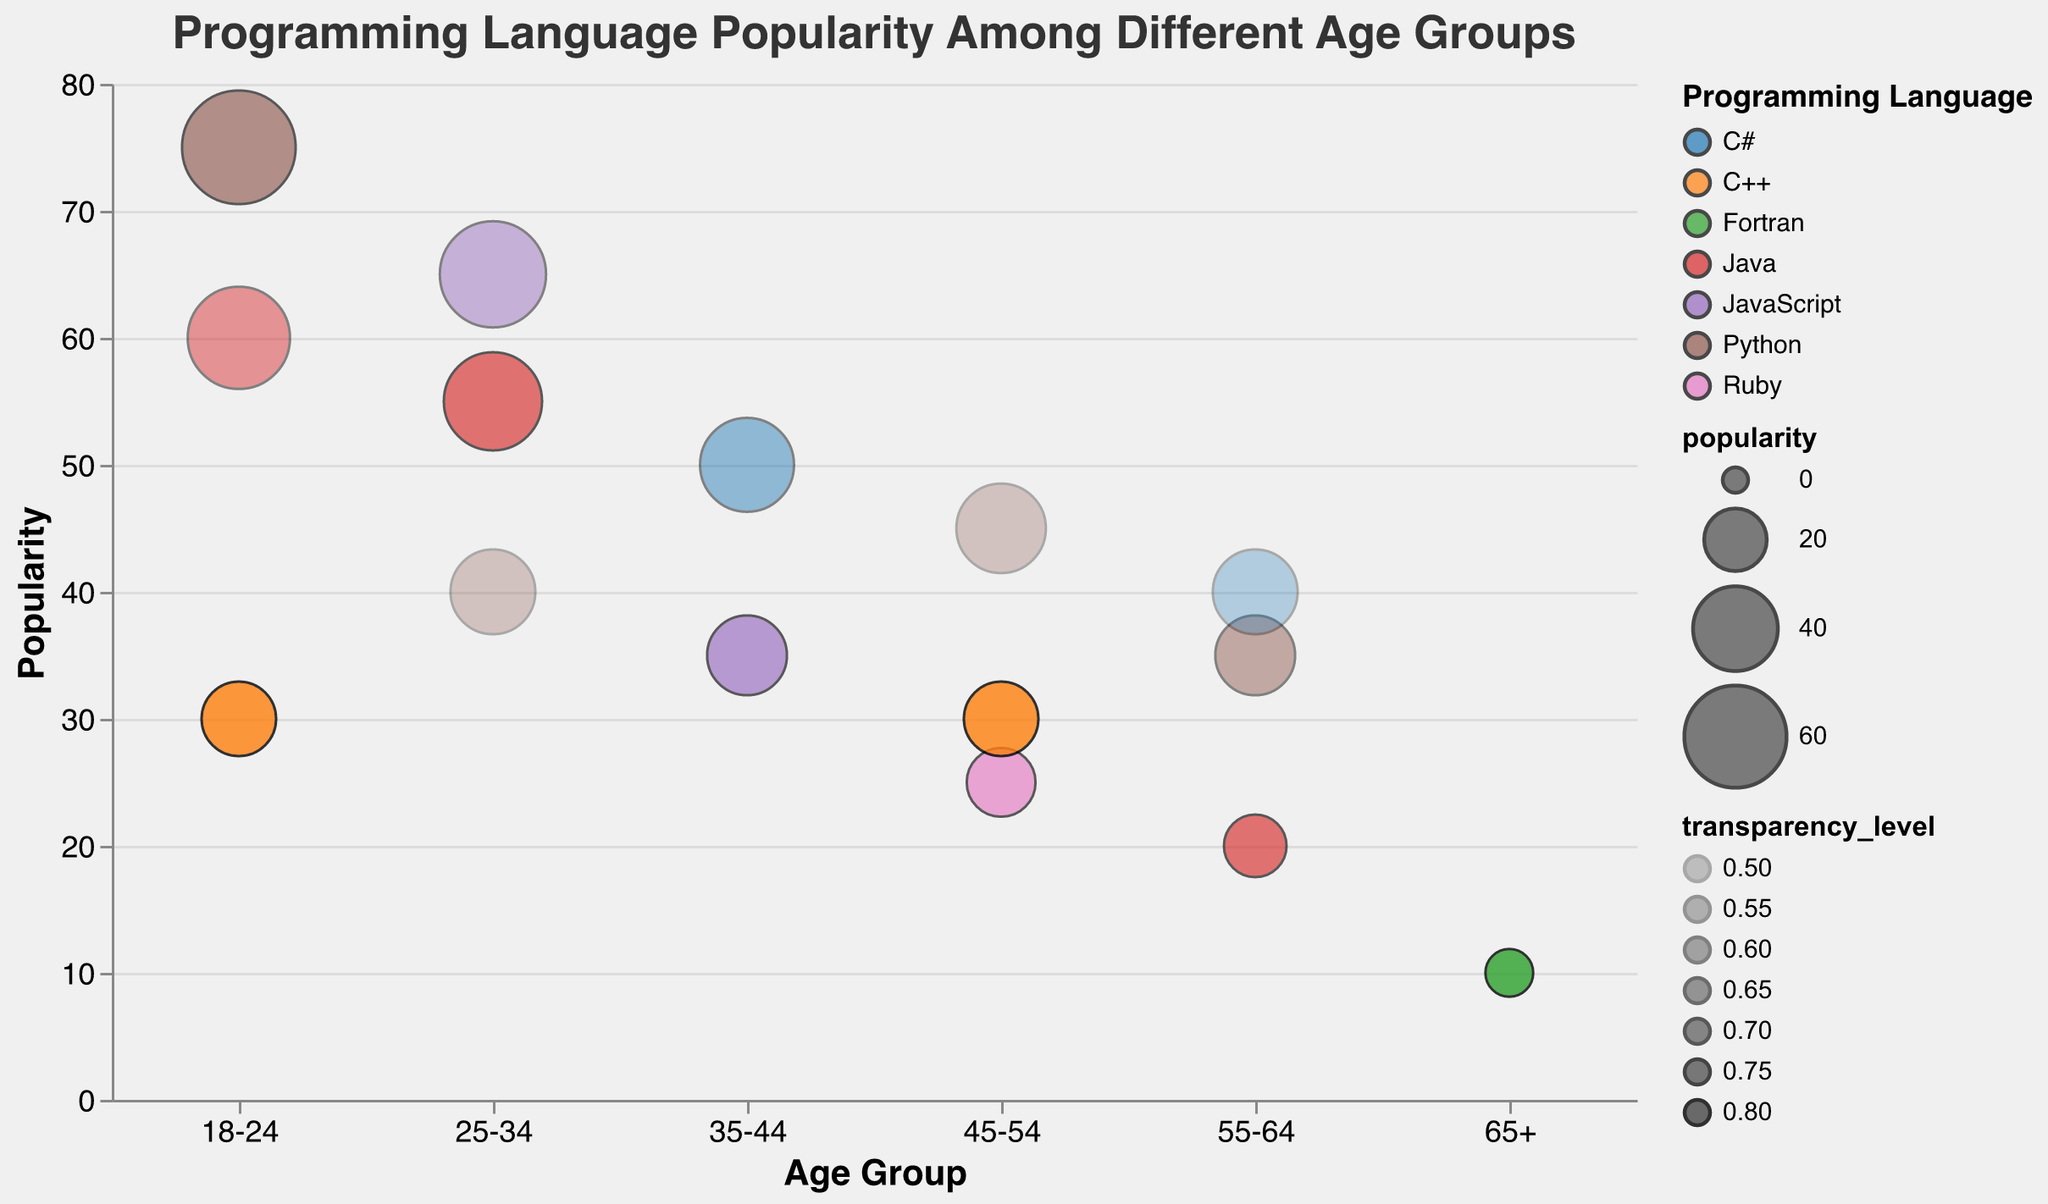What is the most popular programming language for beginners in the 18-24 age group? To find this, look at the age group '18-24' and observe the bubbles with the experience level 'Beginner'. Compare the popularity sizes of these bubbles. The bubble with the largest size represents the most popular language.
Answer: Python Which programming language has the lowest transparency level? Look at the transparency levels of all the bubbles. The programming language associated with the lowest transparency level is identified.
Answer: Python (25-34, Advanced) Among the 25-34 age group, which experience level has the highest popularity for JavaScript? Observe the bubbles in the '25-34' age group and identify the ones related to 'JavaScript'. Compare their experience levels. The highest popularity corresponds to the 'Intermediate' experience level.
Answer: Intermediate Compare the popularity of C++ between the 18-24 age group and the 45-54 age group. Which age group finds C++ more popular? Locate the bubbles for 'C++' in both age groups, 18-24 and 45-54. Compare the sizes of these bubbles to determine which one is larger.
Answer: 18-24 What is the average popularity of Python across all age groups? Find the bubbles representing 'Python' across all age groups. Add their popularity values and divide the sum by the number of Python data points. (75 for 18-24, 40 for 25-34, 45 for 45-54, 35 for 55-64) So, avg = (75 + 40 + 45 + 35) / 4 = 195 / 4 = 48.75
Answer: 48.75 Which age group has the highest number of different programming languages? Count the number of unique programming languages in each age group. The group with the highest count is the answer.
Answer: 25-34 How does the popularity of Java for beginners change from the 18-24 age group to the 55-64 age group? Identify the popularity values for Java, Beginner, in the 18-24 age group and the 55-64 age group. Compare these values to observe the change. 18-24 has 60, while 55-64 has 20.
Answer: It decreases What is the total popularity of advanced programmers using C++? Sum the popularity values for all bubbles representing 'C++' and 'Advanced'. (30 for 18-24 and 30 for 45-54). Total = 30 + 30 = 60.
Answer: 60 Which programming language is represented by the most transparent bubble? Locate the bubble with the highest transparency level and identify the related programming language. This requires checking the transparency levels in the data.
Answer: C++ 